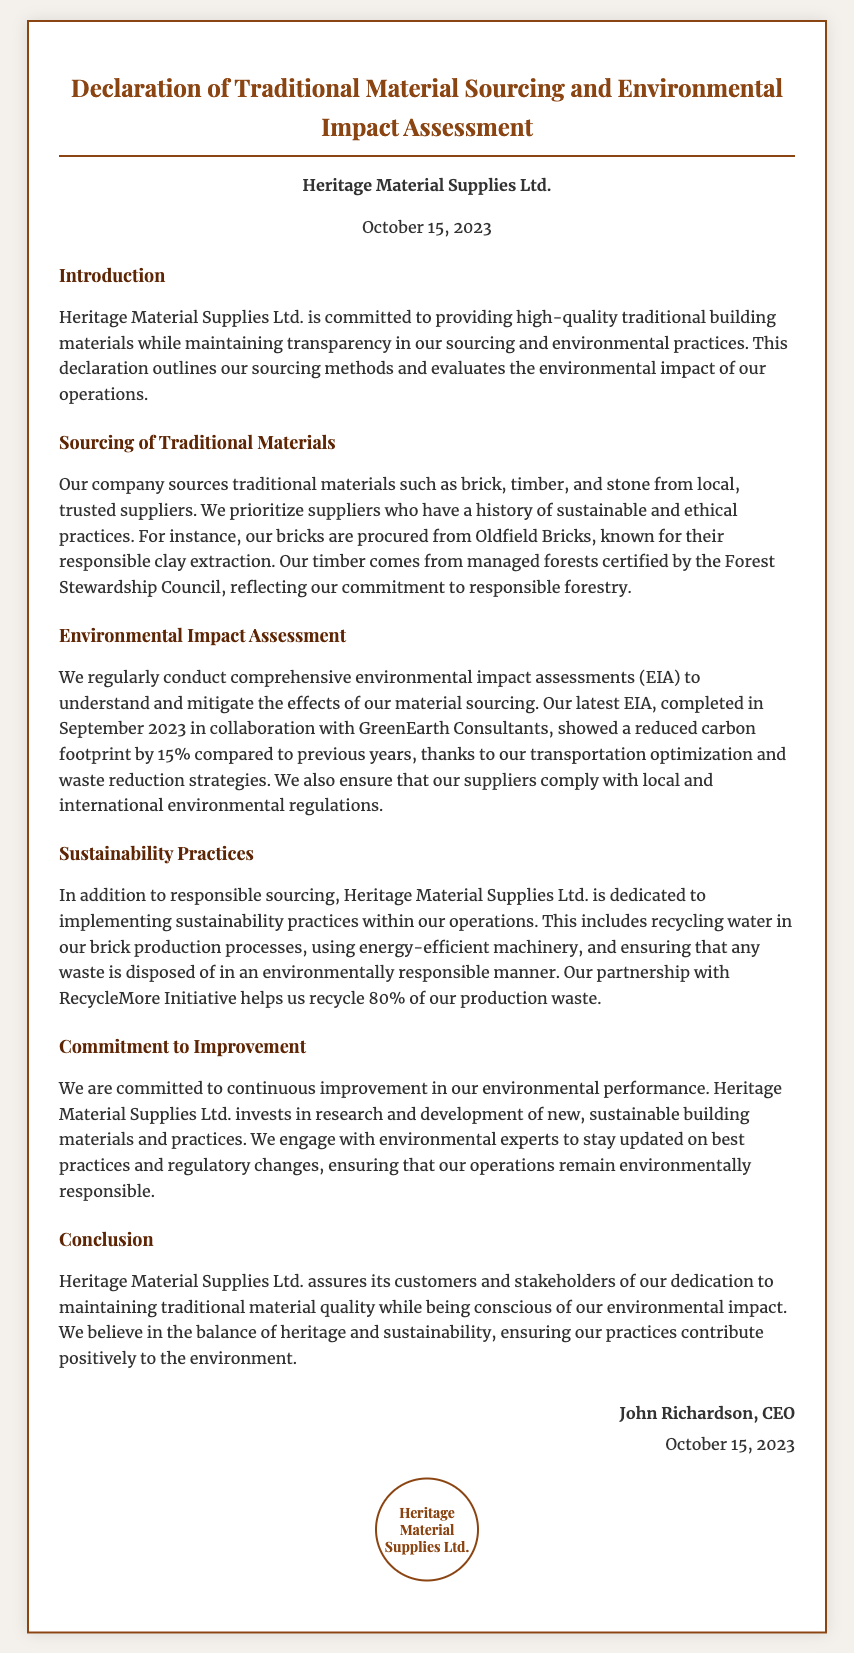What is the name of the company? The name of the company is featured prominently at the top of the document and is stated as Heritage Material Supplies Ltd.
Answer: Heritage Material Supplies Ltd When was the declaration signed? The date of the declaration is included in the company information section, stating it was signed on October 15, 2023.
Answer: October 15, 2023 What type of materials does the company source? The document specifies that the company sources traditional materials such as brick, timber, and stone.
Answer: Brick, timber, and stone Who conducted the latest Environmental Impact Assessment? The organization that collaborated on the Environmental Impact Assessment is mentioned in the document as GreenEarth Consultants.
Answer: GreenEarth Consultants By what percentage has the carbon footprint been reduced? The document states a reduction in carbon footprint by 15% compared to previous years as a result of their initiatives.
Answer: 15% What is one sustainability practice implemented by the company? The document lists several practices, and one mentioned is recycling water in brick production processes.
Answer: Recycling water What certification does the timber sourcing comply with? The document mentions that the timber comes from managed forests certified by the Forest Stewardship Council.
Answer: Forest Stewardship Council What is the CEO's name who signed the declaration? The signature section of the document identifies the CEO as John Richardson.
Answer: John Richardson What initiative helps recycle production waste? The document mentions a partnership with RecycleMore Initiative to recycle 80% of production waste.
Answer: RecycleMore Initiative 